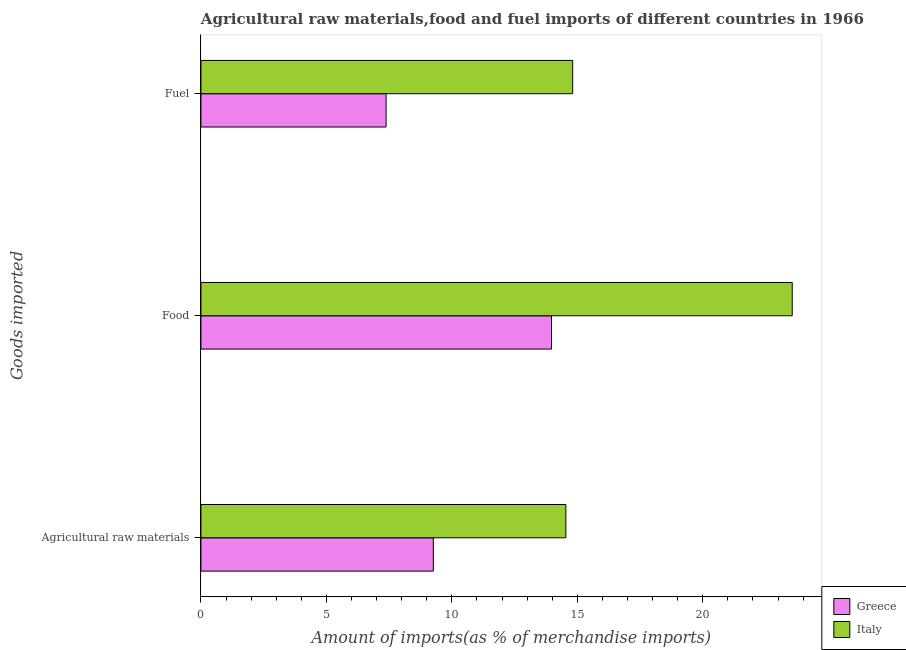Are the number of bars per tick equal to the number of legend labels?
Offer a terse response. Yes. How many bars are there on the 3rd tick from the top?
Keep it short and to the point. 2. How many bars are there on the 2nd tick from the bottom?
Your answer should be very brief. 2. What is the label of the 3rd group of bars from the top?
Offer a terse response. Agricultural raw materials. What is the percentage of food imports in Greece?
Provide a succinct answer. 13.97. Across all countries, what is the maximum percentage of fuel imports?
Provide a succinct answer. 14.82. Across all countries, what is the minimum percentage of food imports?
Keep it short and to the point. 13.97. In which country was the percentage of fuel imports maximum?
Keep it short and to the point. Italy. What is the total percentage of food imports in the graph?
Your answer should be compact. 37.54. What is the difference between the percentage of raw materials imports in Italy and that in Greece?
Keep it short and to the point. 5.28. What is the difference between the percentage of raw materials imports in Greece and the percentage of fuel imports in Italy?
Offer a terse response. -5.55. What is the average percentage of raw materials imports per country?
Offer a very short reply. 11.9. What is the difference between the percentage of food imports and percentage of fuel imports in Italy?
Offer a terse response. 8.75. What is the ratio of the percentage of raw materials imports in Italy to that in Greece?
Your answer should be very brief. 1.57. Is the percentage of raw materials imports in Italy less than that in Greece?
Your response must be concise. No. What is the difference between the highest and the second highest percentage of food imports?
Offer a very short reply. 9.59. What is the difference between the highest and the lowest percentage of raw materials imports?
Provide a succinct answer. 5.28. In how many countries, is the percentage of food imports greater than the average percentage of food imports taken over all countries?
Your answer should be compact. 1. What is the difference between two consecutive major ticks on the X-axis?
Ensure brevity in your answer.  5. Are the values on the major ticks of X-axis written in scientific E-notation?
Your answer should be compact. No. Where does the legend appear in the graph?
Your answer should be very brief. Bottom right. How many legend labels are there?
Keep it short and to the point. 2. What is the title of the graph?
Keep it short and to the point. Agricultural raw materials,food and fuel imports of different countries in 1966. What is the label or title of the X-axis?
Offer a terse response. Amount of imports(as % of merchandise imports). What is the label or title of the Y-axis?
Your answer should be very brief. Goods imported. What is the Amount of imports(as % of merchandise imports) of Greece in Agricultural raw materials?
Provide a succinct answer. 9.26. What is the Amount of imports(as % of merchandise imports) in Italy in Agricultural raw materials?
Give a very brief answer. 14.54. What is the Amount of imports(as % of merchandise imports) of Greece in Food?
Make the answer very short. 13.97. What is the Amount of imports(as % of merchandise imports) in Italy in Food?
Your response must be concise. 23.57. What is the Amount of imports(as % of merchandise imports) in Greece in Fuel?
Ensure brevity in your answer.  7.38. What is the Amount of imports(as % of merchandise imports) of Italy in Fuel?
Your answer should be very brief. 14.82. Across all Goods imported, what is the maximum Amount of imports(as % of merchandise imports) in Greece?
Offer a very short reply. 13.97. Across all Goods imported, what is the maximum Amount of imports(as % of merchandise imports) of Italy?
Your answer should be compact. 23.57. Across all Goods imported, what is the minimum Amount of imports(as % of merchandise imports) in Greece?
Your response must be concise. 7.38. Across all Goods imported, what is the minimum Amount of imports(as % of merchandise imports) of Italy?
Your response must be concise. 14.54. What is the total Amount of imports(as % of merchandise imports) in Greece in the graph?
Make the answer very short. 30.61. What is the total Amount of imports(as % of merchandise imports) of Italy in the graph?
Offer a very short reply. 52.92. What is the difference between the Amount of imports(as % of merchandise imports) of Greece in Agricultural raw materials and that in Food?
Your answer should be compact. -4.71. What is the difference between the Amount of imports(as % of merchandise imports) in Italy in Agricultural raw materials and that in Food?
Offer a very short reply. -9.02. What is the difference between the Amount of imports(as % of merchandise imports) of Greece in Agricultural raw materials and that in Fuel?
Keep it short and to the point. 1.88. What is the difference between the Amount of imports(as % of merchandise imports) of Italy in Agricultural raw materials and that in Fuel?
Provide a short and direct response. -0.27. What is the difference between the Amount of imports(as % of merchandise imports) in Greece in Food and that in Fuel?
Your answer should be very brief. 6.59. What is the difference between the Amount of imports(as % of merchandise imports) of Italy in Food and that in Fuel?
Your response must be concise. 8.75. What is the difference between the Amount of imports(as % of merchandise imports) of Greece in Agricultural raw materials and the Amount of imports(as % of merchandise imports) of Italy in Food?
Give a very brief answer. -14.3. What is the difference between the Amount of imports(as % of merchandise imports) in Greece in Agricultural raw materials and the Amount of imports(as % of merchandise imports) in Italy in Fuel?
Offer a very short reply. -5.55. What is the difference between the Amount of imports(as % of merchandise imports) in Greece in Food and the Amount of imports(as % of merchandise imports) in Italy in Fuel?
Give a very brief answer. -0.84. What is the average Amount of imports(as % of merchandise imports) of Greece per Goods imported?
Make the answer very short. 10.2. What is the average Amount of imports(as % of merchandise imports) in Italy per Goods imported?
Offer a very short reply. 17.64. What is the difference between the Amount of imports(as % of merchandise imports) in Greece and Amount of imports(as % of merchandise imports) in Italy in Agricultural raw materials?
Your answer should be very brief. -5.28. What is the difference between the Amount of imports(as % of merchandise imports) in Greece and Amount of imports(as % of merchandise imports) in Italy in Food?
Your answer should be compact. -9.59. What is the difference between the Amount of imports(as % of merchandise imports) in Greece and Amount of imports(as % of merchandise imports) in Italy in Fuel?
Keep it short and to the point. -7.44. What is the ratio of the Amount of imports(as % of merchandise imports) of Greece in Agricultural raw materials to that in Food?
Make the answer very short. 0.66. What is the ratio of the Amount of imports(as % of merchandise imports) of Italy in Agricultural raw materials to that in Food?
Offer a terse response. 0.62. What is the ratio of the Amount of imports(as % of merchandise imports) of Greece in Agricultural raw materials to that in Fuel?
Your answer should be compact. 1.25. What is the ratio of the Amount of imports(as % of merchandise imports) in Italy in Agricultural raw materials to that in Fuel?
Provide a succinct answer. 0.98. What is the ratio of the Amount of imports(as % of merchandise imports) in Greece in Food to that in Fuel?
Offer a very short reply. 1.89. What is the ratio of the Amount of imports(as % of merchandise imports) of Italy in Food to that in Fuel?
Provide a succinct answer. 1.59. What is the difference between the highest and the second highest Amount of imports(as % of merchandise imports) of Greece?
Keep it short and to the point. 4.71. What is the difference between the highest and the second highest Amount of imports(as % of merchandise imports) of Italy?
Give a very brief answer. 8.75. What is the difference between the highest and the lowest Amount of imports(as % of merchandise imports) in Greece?
Your answer should be compact. 6.59. What is the difference between the highest and the lowest Amount of imports(as % of merchandise imports) in Italy?
Offer a terse response. 9.02. 